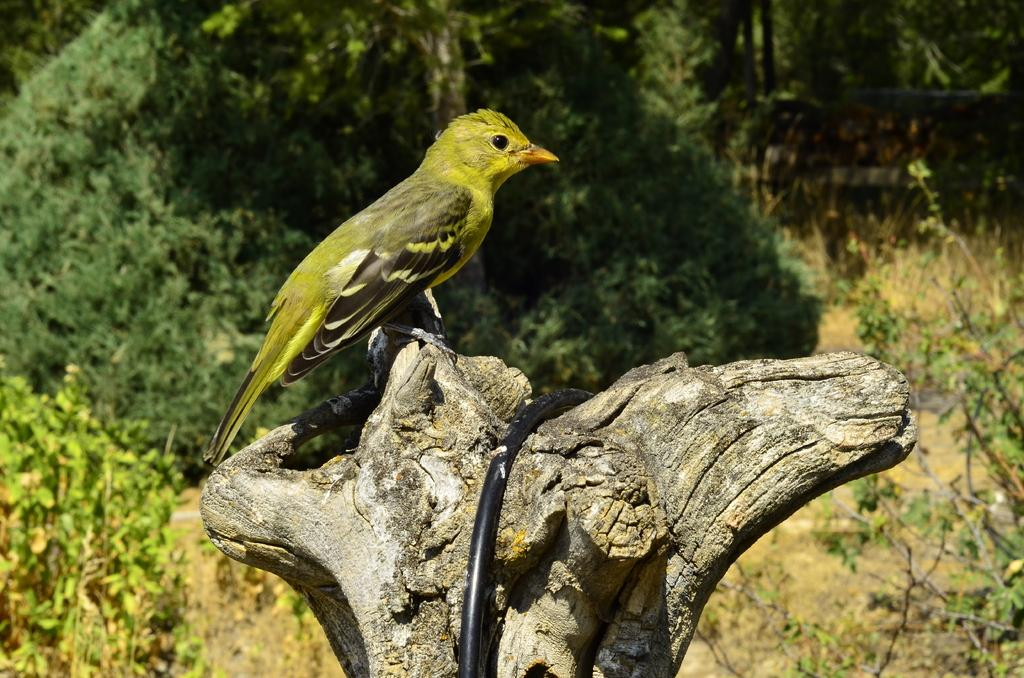What type of animal can be seen in the image? There is a bird in the image. Where is the bird located? The bird is on a wooden trunk. What can be seen in the background of the image? There are trees in the background of the image. What type of soda is the bird drinking from the wooden trunk in the image? There is no soda present in the image; the bird is simply perched on the wooden trunk. How many women are visible in the image? There are no women present in the image; it features a bird on a wooden trunk with trees in the background. 